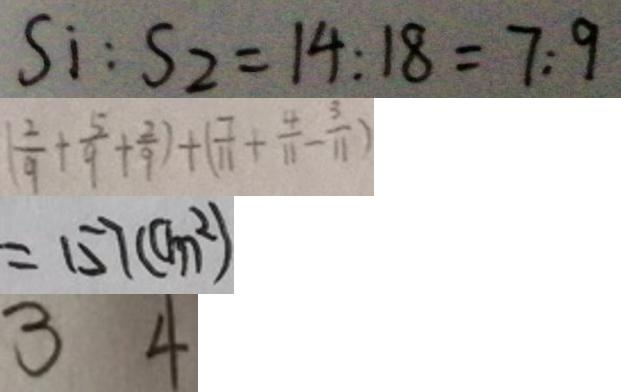<formula> <loc_0><loc_0><loc_500><loc_500>S _ { i } : S _ { 2 } = 1 4 : 1 8 = 7 : 9 
 ( \frac { 2 } { 9 } + \frac { 5 } { 9 } + \frac { 2 } { 9 } ) + ( \frac { 7 } { 1 1 } + \frac { 4 } { 1 1 } - \frac { 3 } { 1 1 } ) 
 = 1 5 7 ( c m ^ { 2 } ) 
 3 4</formula> 